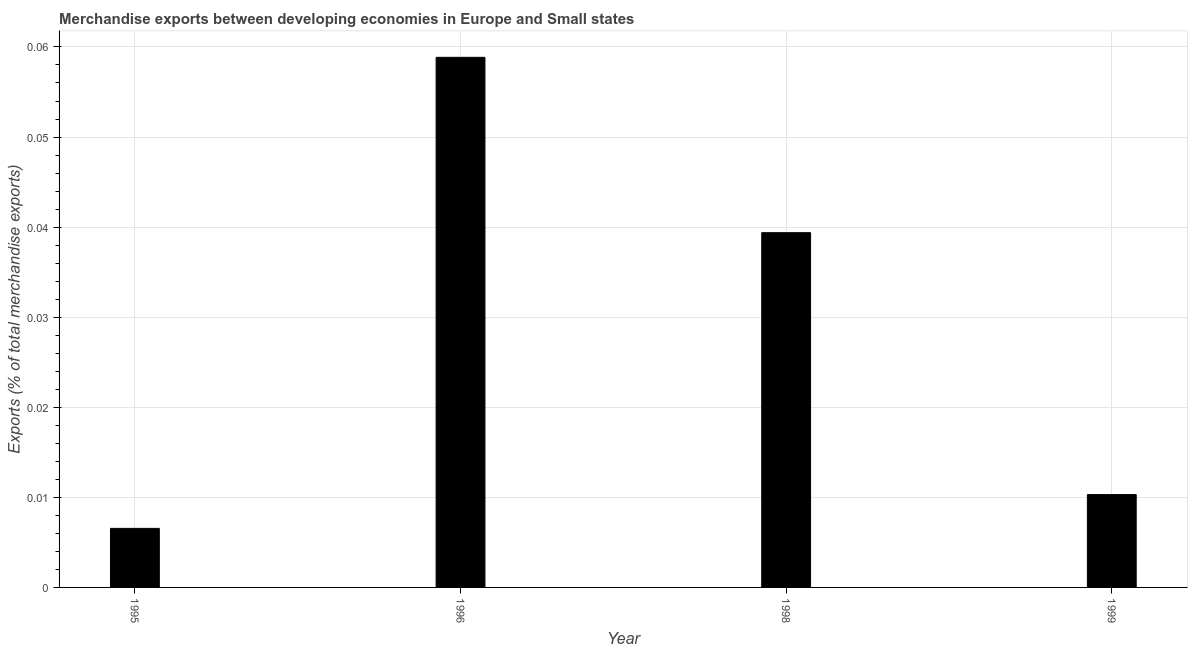Does the graph contain any zero values?
Your answer should be compact. No. What is the title of the graph?
Your response must be concise. Merchandise exports between developing economies in Europe and Small states. What is the label or title of the X-axis?
Provide a short and direct response. Year. What is the label or title of the Y-axis?
Keep it short and to the point. Exports (% of total merchandise exports). What is the merchandise exports in 1995?
Your answer should be compact. 0.01. Across all years, what is the maximum merchandise exports?
Your answer should be compact. 0.06. Across all years, what is the minimum merchandise exports?
Provide a succinct answer. 0.01. In which year was the merchandise exports maximum?
Ensure brevity in your answer.  1996. In which year was the merchandise exports minimum?
Your answer should be very brief. 1995. What is the sum of the merchandise exports?
Provide a succinct answer. 0.12. What is the difference between the merchandise exports in 1995 and 1999?
Offer a very short reply. -0. What is the average merchandise exports per year?
Ensure brevity in your answer.  0.03. What is the median merchandise exports?
Make the answer very short. 0.02. In how many years, is the merchandise exports greater than 0.002 %?
Offer a terse response. 4. Do a majority of the years between 1998 and 1995 (inclusive) have merchandise exports greater than 0.058 %?
Offer a terse response. Yes. What is the ratio of the merchandise exports in 1995 to that in 1998?
Offer a terse response. 0.17. Is the difference between the merchandise exports in 1996 and 1999 greater than the difference between any two years?
Keep it short and to the point. No. What is the difference between the highest and the second highest merchandise exports?
Offer a terse response. 0.02. What is the difference between the highest and the lowest merchandise exports?
Offer a very short reply. 0.05. How many bars are there?
Make the answer very short. 4. Are all the bars in the graph horizontal?
Provide a succinct answer. No. What is the difference between two consecutive major ticks on the Y-axis?
Give a very brief answer. 0.01. What is the Exports (% of total merchandise exports) of 1995?
Give a very brief answer. 0.01. What is the Exports (% of total merchandise exports) in 1996?
Your answer should be very brief. 0.06. What is the Exports (% of total merchandise exports) of 1998?
Keep it short and to the point. 0.04. What is the Exports (% of total merchandise exports) in 1999?
Provide a succinct answer. 0.01. What is the difference between the Exports (% of total merchandise exports) in 1995 and 1996?
Offer a terse response. -0.05. What is the difference between the Exports (% of total merchandise exports) in 1995 and 1998?
Your response must be concise. -0.03. What is the difference between the Exports (% of total merchandise exports) in 1995 and 1999?
Offer a very short reply. -0. What is the difference between the Exports (% of total merchandise exports) in 1996 and 1998?
Your answer should be compact. 0.02. What is the difference between the Exports (% of total merchandise exports) in 1996 and 1999?
Offer a terse response. 0.05. What is the difference between the Exports (% of total merchandise exports) in 1998 and 1999?
Your answer should be very brief. 0.03. What is the ratio of the Exports (% of total merchandise exports) in 1995 to that in 1996?
Offer a terse response. 0.11. What is the ratio of the Exports (% of total merchandise exports) in 1995 to that in 1998?
Provide a succinct answer. 0.17. What is the ratio of the Exports (% of total merchandise exports) in 1995 to that in 1999?
Your answer should be very brief. 0.64. What is the ratio of the Exports (% of total merchandise exports) in 1996 to that in 1998?
Make the answer very short. 1.49. What is the ratio of the Exports (% of total merchandise exports) in 1996 to that in 1999?
Keep it short and to the point. 5.71. What is the ratio of the Exports (% of total merchandise exports) in 1998 to that in 1999?
Keep it short and to the point. 3.82. 